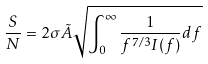Convert formula to latex. <formula><loc_0><loc_0><loc_500><loc_500>\frac { S } { N } = 2 \sigma \tilde { A } \sqrt { \int _ { 0 } ^ { \infty } \frac { 1 } { f ^ { 7 / 3 } I ( f ) } d f }</formula> 